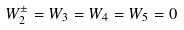<formula> <loc_0><loc_0><loc_500><loc_500>W _ { 2 } ^ { \pm } = W _ { 3 } = W _ { 4 } = W _ { 5 } = 0</formula> 